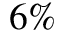Convert formula to latex. <formula><loc_0><loc_0><loc_500><loc_500>6 \%</formula> 